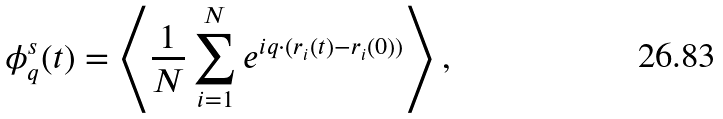<formula> <loc_0><loc_0><loc_500><loc_500>\phi _ { q } ^ { s } ( t ) = \left < \frac { 1 } { N } \sum _ { i = 1 } ^ { N } e ^ { i { q } \cdot ( { r } _ { i } ( t ) - { r } _ { i } ( 0 ) ) } \right > ,</formula> 